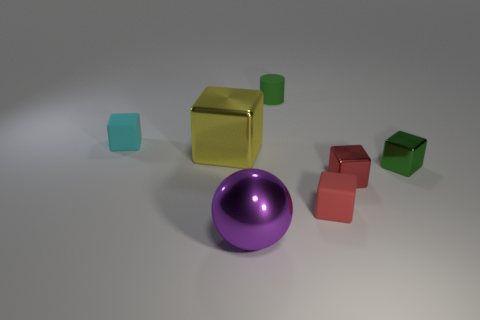There is a large thing that is right of the big metallic cube; does it have the same shape as the large yellow shiny thing?
Your answer should be compact. No. What number of tiny yellow matte things are there?
Your answer should be compact. 0. How many green matte cylinders are the same size as the green metallic object?
Your response must be concise. 1. What is the material of the large purple sphere?
Ensure brevity in your answer.  Metal. There is a rubber cylinder; is its color the same as the small metal object on the left side of the tiny green block?
Your answer should be compact. No. Is there anything else that is the same size as the cyan object?
Your response must be concise. Yes. How big is the thing that is both to the right of the small green cylinder and in front of the small red shiny block?
Offer a terse response. Small. There is a large purple thing that is the same material as the green cube; what is its shape?
Your answer should be compact. Sphere. Is the tiny cyan cube made of the same material as the green object that is on the right side of the small green cylinder?
Give a very brief answer. No. Are there any large metal balls that are to the right of the tiny rubber block that is right of the big sphere?
Provide a succinct answer. No. 